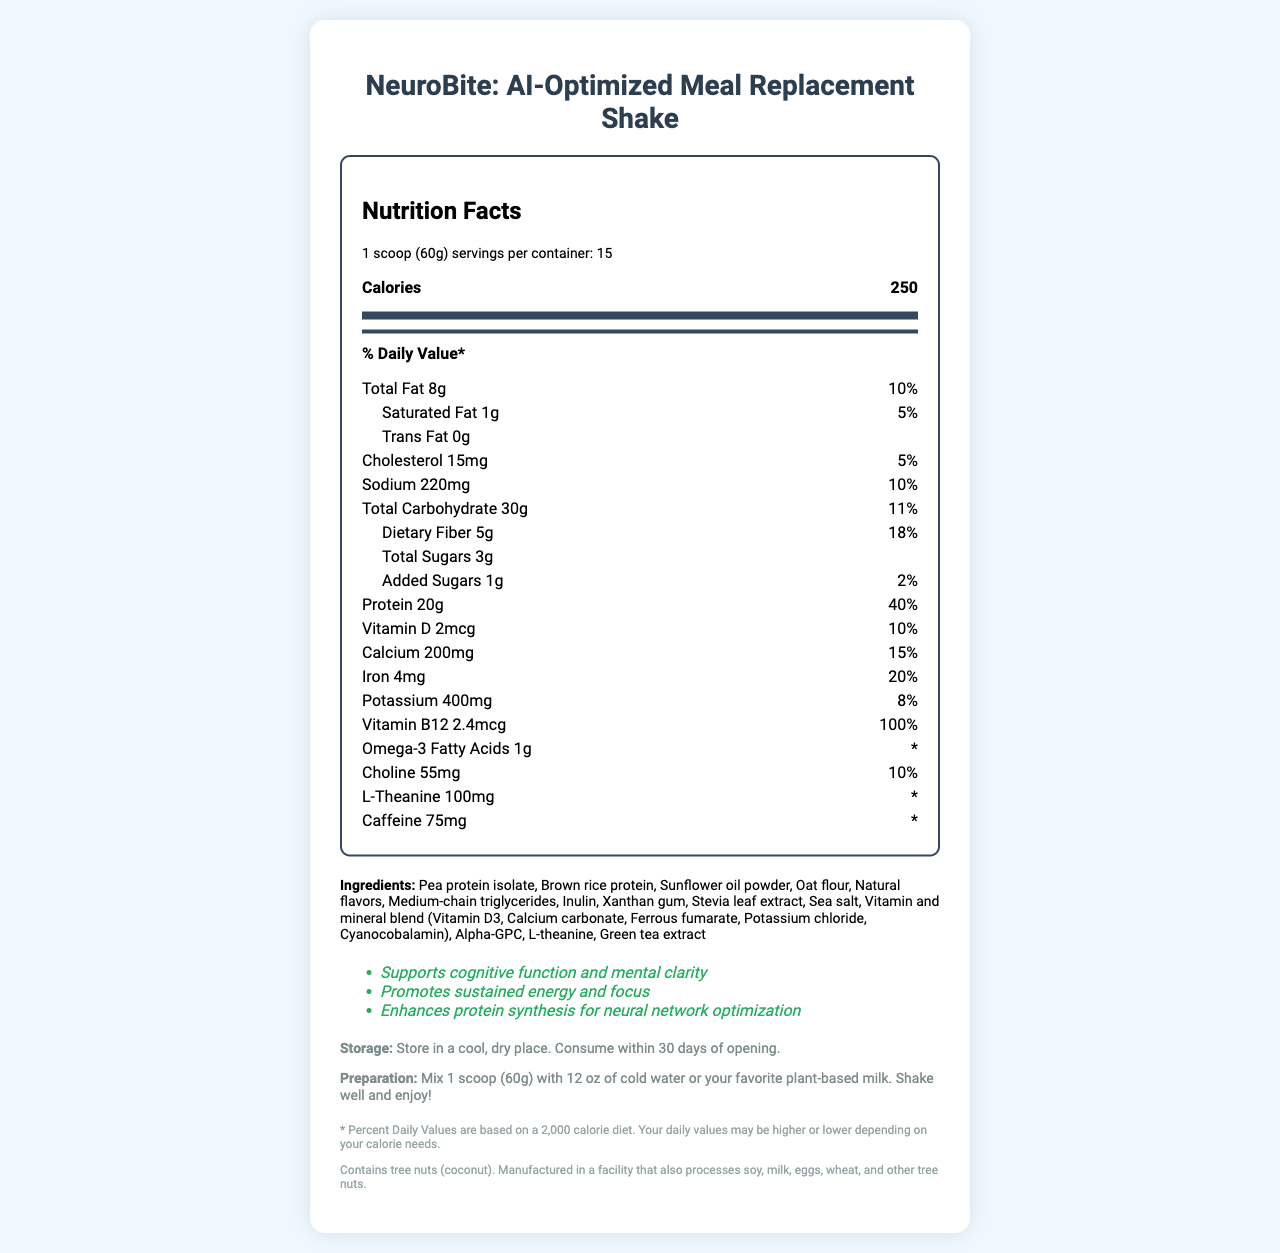what is the serving size for the meal replacement shake? The serving size is clearly indicated at the top of the nutrition facts as "1 scoop (60g)".
Answer: 1 scoop (60g) how many calories are in one serving? The document states that there are 250 calories per serving in the nutrition facts section.
Answer: 250 what percentage of the daily value is the protein content? The protein content daily value percentage is listed as 40% in the nutrition facts.
Answer: 40% how much added sugar is in each serving? Each serving contains 1g of added sugars as per the nutrition facts section.
Answer: 1g list the ingredients of the meal replacement shake. The ingredients section lists all the components used in the shake.
Answer: Pea protein isolate, Brown rice protein, Sunflower oil powder, Oat flour, Natural flavors, Medium-chain triglycerides, Inulin, Xanthan gum, Stevia leaf extract, Sea salt, Vitamin and mineral blend (Vitamin D3, Calcium carbonate, Ferrous fumarate, Potassium chloride, Cyanocobalamin), Alpha-GPC, L-theanine, Green tea extract which nutrient has the highest daily value percentage? A. Vitamin D B. Iron C. Protein D. Potassium The protein content has the highest daily value percentage at 40%, as shown in the nutrition facts.
Answer: C how much caffeine is in each serving? A. 50mg B. 75mg C. 100mg D. 125mg Each serving contains 75mg of caffeine according to the nutrition facts section.
Answer: B is the product suitable for people with tree nut allergies? The allergen information mentions that the product contains tree nuts (coconut).
Answer: No summarize the main idea of the document. The document is a comprehensive nutrition facts label for the NeuroBite: AI-Optimized Meal Replacement Shake, containing all necessary nutritional and usage information for consumers.
Answer: This document provides detailed nutritional information for the NeuroBite: AI-Optimized Meal Replacement Shake, including the serving size, calories, and percentages of daily values for various nutrients. It also lists ingredients, storage and preparation instructions, health claims, and allergen information. what is the recommended storage condition for the product? The storage instructions provided in the document recommend keeping the product in a cool, dry place and consuming it within 30 days of opening.
Answer: Store in a cool, dry place. Consume within 30 days of opening. how many grams of dietary fiber are in each serving? The nutrition facts state that each serving contains 5g of dietary fiber.
Answer: 5g does the document provide information on the environmental impact of the product? The document does not include any details regarding the environmental impact of the product.
Answer: Not enough information 